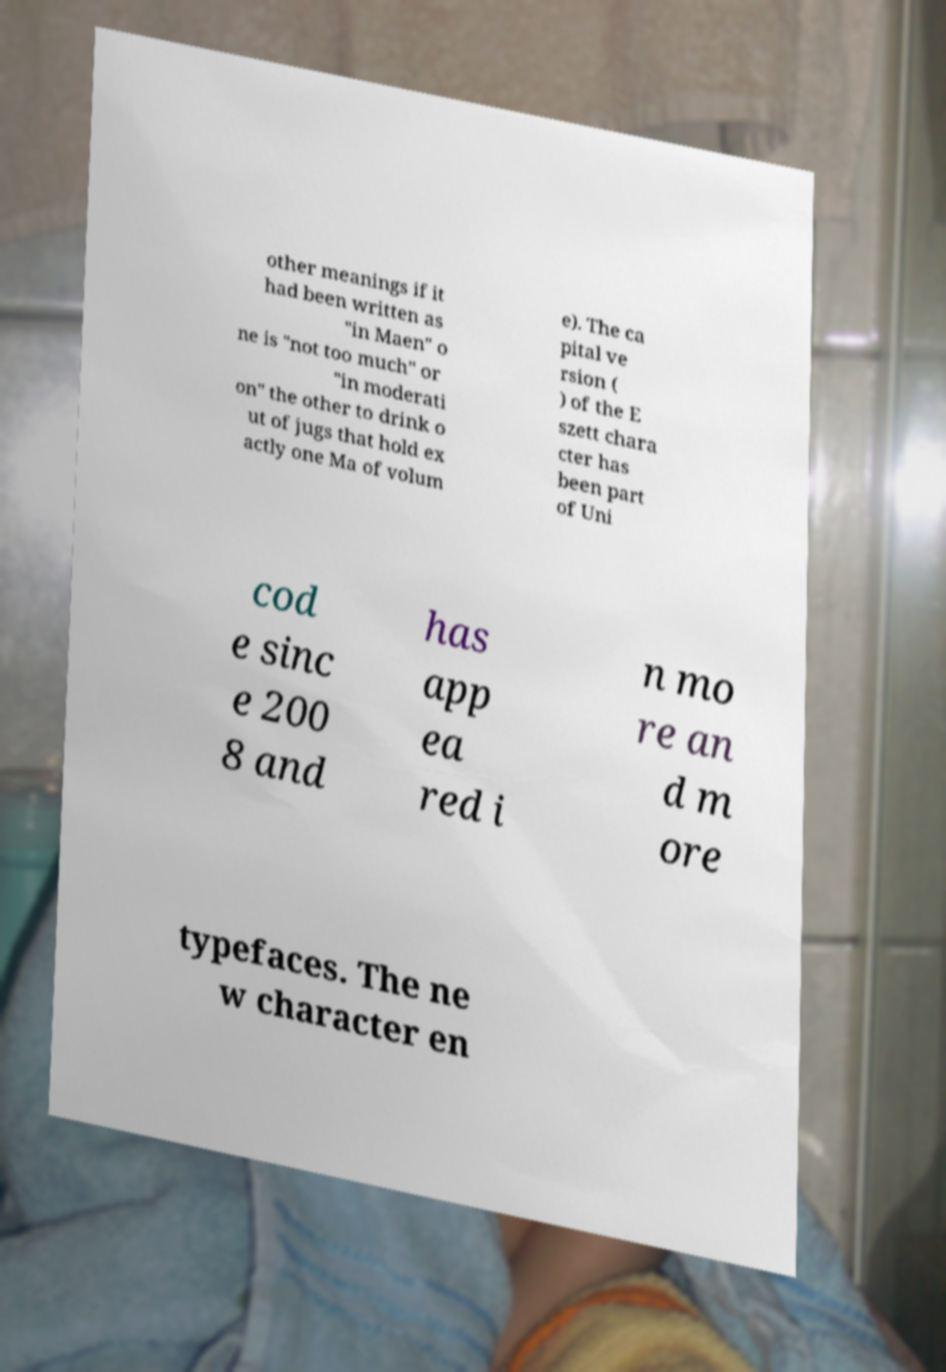Please read and relay the text visible in this image. What does it say? other meanings if it had been written as "in Maen" o ne is "not too much" or "in moderati on" the other to drink o ut of jugs that hold ex actly one Ma of volum e). The ca pital ve rsion ( ) of the E szett chara cter has been part of Uni cod e sinc e 200 8 and has app ea red i n mo re an d m ore typefaces. The ne w character en 